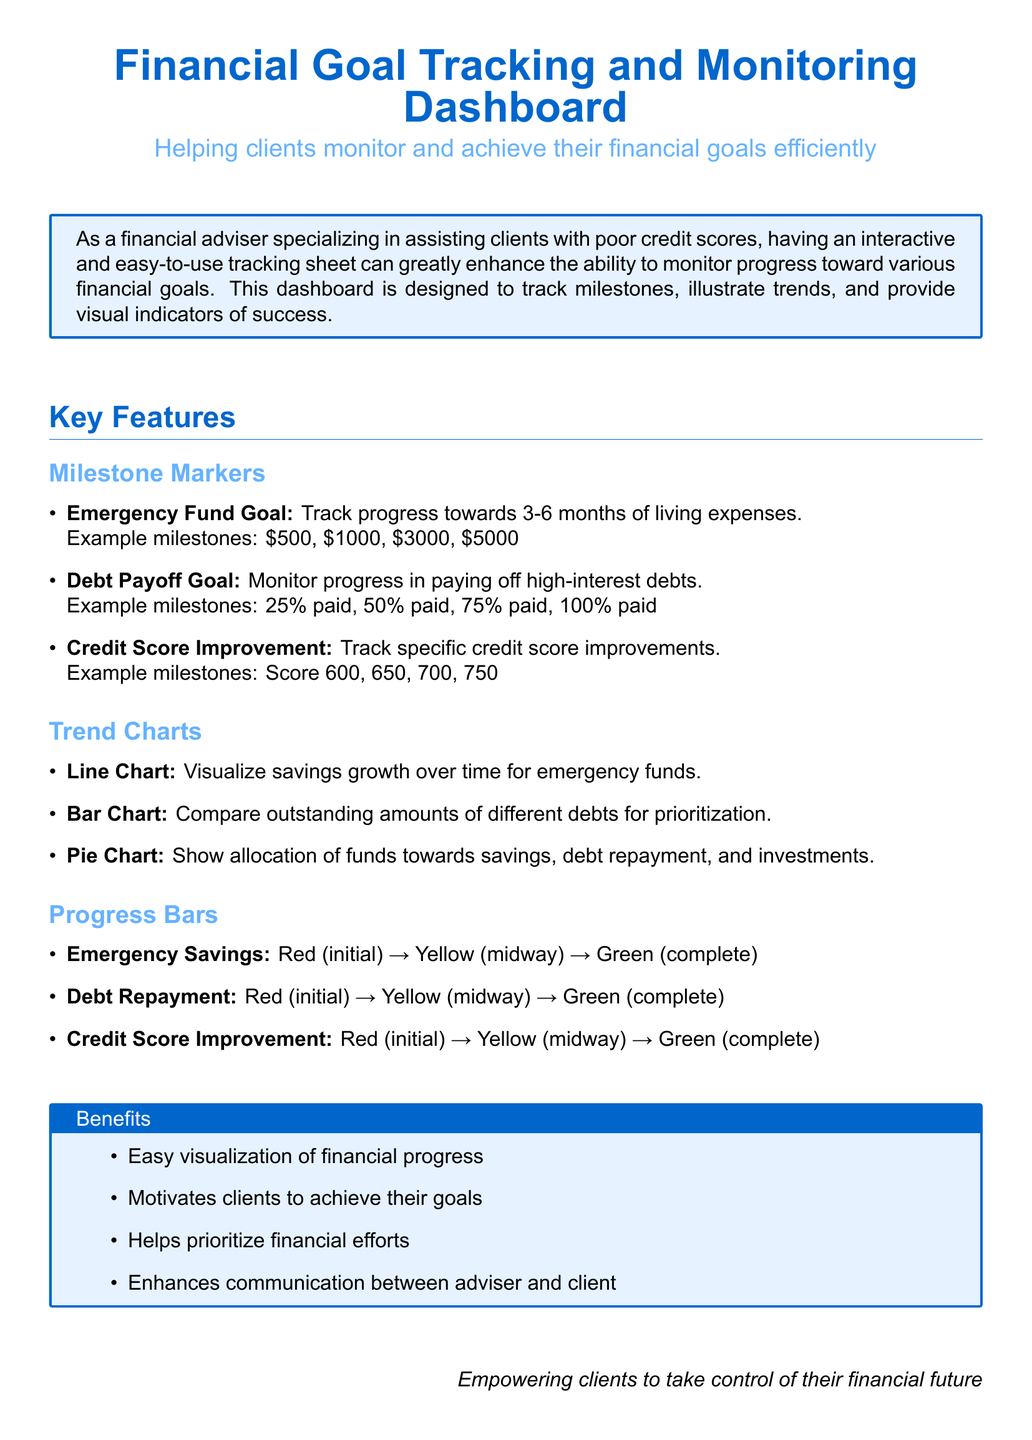What is the title of the document? The title of the document is displayed prominently at the top, emphasizing its purpose.
Answer: Financial Goal Tracking and Monitoring Dashboard What is the subtitle of the document? The subtitle provides additional context on how the dashboard helps clients.
Answer: Helping clients monitor and achieve their financial goals efficiently What are the example milestones for the Emergency Fund Goal? Example milestones are specifically listed to illustrate the progress clients aim to achieve.
Answer: $500, $1000, $3000, $5000 What chart type is used to compare outstanding amounts of different debts? The document specifies the use of a particular chart to facilitate visual comparisons for clients.
Answer: Bar Chart What color indicates complete progress for Emergency Savings? The document defines a color-coded system to represent progress visually.
Answer: Green What are the benefits of using this dashboard? The response outlines the advantages provided to clients and advisers through its use.
Answer: Easy visualization of financial progress What type of tracking is used for Credit Score Improvement? This aspect highlights the specific financial goal the dashboard aims to help clients with.
Answer: Specific credit score improvements At what credit score milestone does the improvement start? Milestones are explicitly mentioned to give clients clear objectives for their credit scores.
Answer: Score 600 